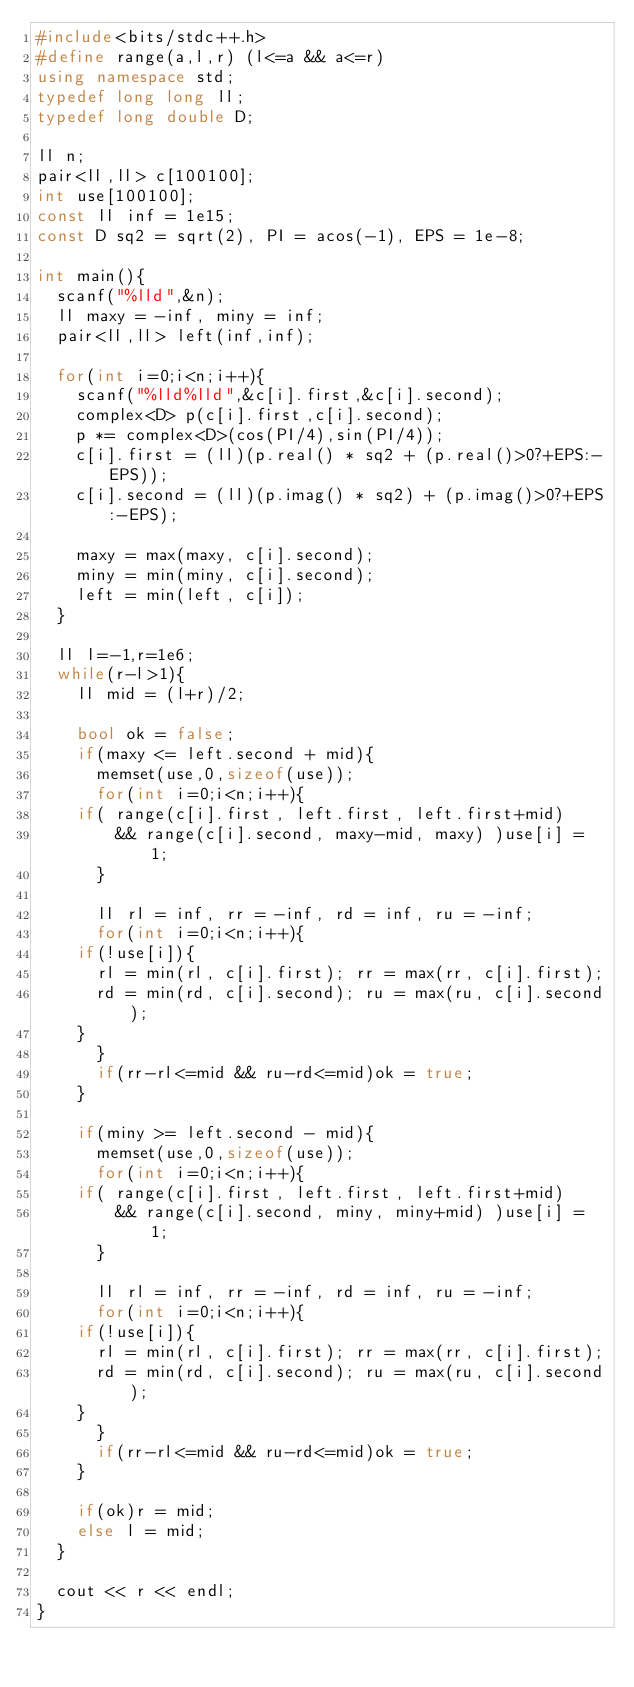Convert code to text. <code><loc_0><loc_0><loc_500><loc_500><_C++_>#include<bits/stdc++.h>
#define range(a,l,r) (l<=a && a<=r)
using namespace std;
typedef long long ll;
typedef long double D;

ll n;
pair<ll,ll> c[100100];
int use[100100];
const ll inf = 1e15;
const D sq2 = sqrt(2), PI = acos(-1), EPS = 1e-8;

int main(){
  scanf("%lld",&n);
  ll maxy = -inf, miny = inf;
  pair<ll,ll> left(inf,inf);

  for(int i=0;i<n;i++){
    scanf("%lld%lld",&c[i].first,&c[i].second);
    complex<D> p(c[i].first,c[i].second);
    p *= complex<D>(cos(PI/4),sin(PI/4));
    c[i].first = (ll)(p.real() * sq2 + (p.real()>0?+EPS:-EPS));
    c[i].second = (ll)(p.imag() * sq2) + (p.imag()>0?+EPS:-EPS);

    maxy = max(maxy, c[i].second);
    miny = min(miny, c[i].second);
    left = min(left, c[i]);
  }
  
  ll l=-1,r=1e6;
  while(r-l>1){
    ll mid = (l+r)/2;

    bool ok = false;
    if(maxy <= left.second + mid){
      memset(use,0,sizeof(use));
      for(int i=0;i<n;i++){
	if( range(c[i].first, left.first, left.first+mid)
	    && range(c[i].second, maxy-mid, maxy) )use[i] = 1;
      }

      ll rl = inf, rr = -inf, rd = inf, ru = -inf;
      for(int i=0;i<n;i++){
	if(!use[i]){
	  rl = min(rl, c[i].first); rr = max(rr, c[i].first);
	  rd = min(rd, c[i].second); ru = max(ru, c[i].second);
	}
      }
      if(rr-rl<=mid && ru-rd<=mid)ok = true;
    }

    if(miny >= left.second - mid){
      memset(use,0,sizeof(use));
      for(int i=0;i<n;i++){
	if( range(c[i].first, left.first, left.first+mid)
	    && range(c[i].second, miny, miny+mid) )use[i] = 1;
      }

      ll rl = inf, rr = -inf, rd = inf, ru = -inf;
      for(int i=0;i<n;i++){
	if(!use[i]){
	  rl = min(rl, c[i].first); rr = max(rr, c[i].first);
	  rd = min(rd, c[i].second); ru = max(ru, c[i].second);
	}
      }
      if(rr-rl<=mid && ru-rd<=mid)ok = true;
    }

    if(ok)r = mid;
    else l = mid;
  }

  cout << r << endl;
}</code> 